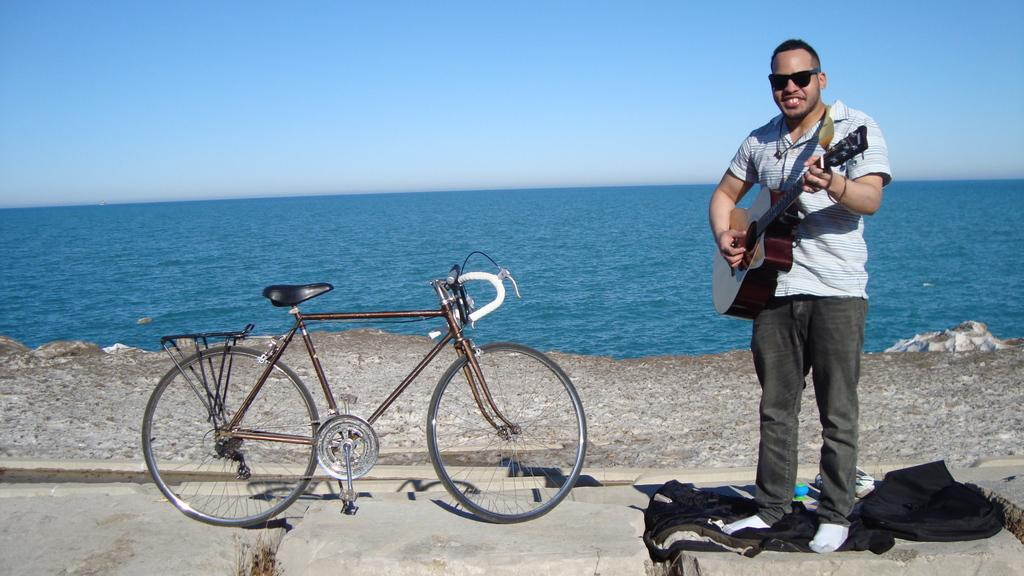What is the main subject of the image? The main subject of the image is a man. What is the man doing in the image? The man is standing in the image. What object is the man holding in his hand? The man is holding a guitar in his hand. What can be seen to the left of the image? There is a bicycle to the left of the image. What is visible in the background of the image? The sky and water are visible in the background of the image. What type of holiday is the man celebrating in the image? There is no indication of a holiday in the image; it simply shows a man standing with a guitar. Where is the middle of the image located? The concept of a "middle" of the image is abstract and cannot be definitively answered based on the provided facts. 